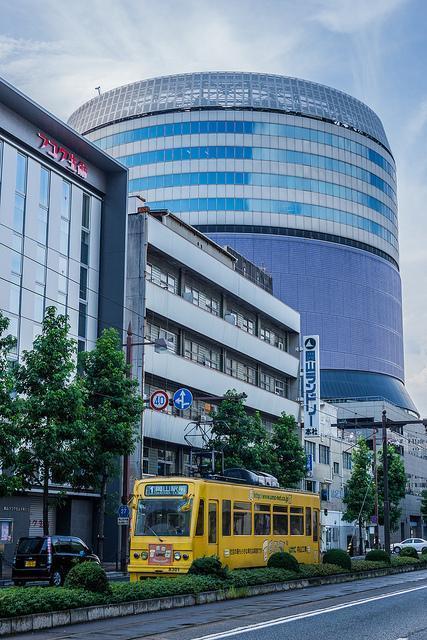How many cars are in the picture?
Give a very brief answer. 1. 